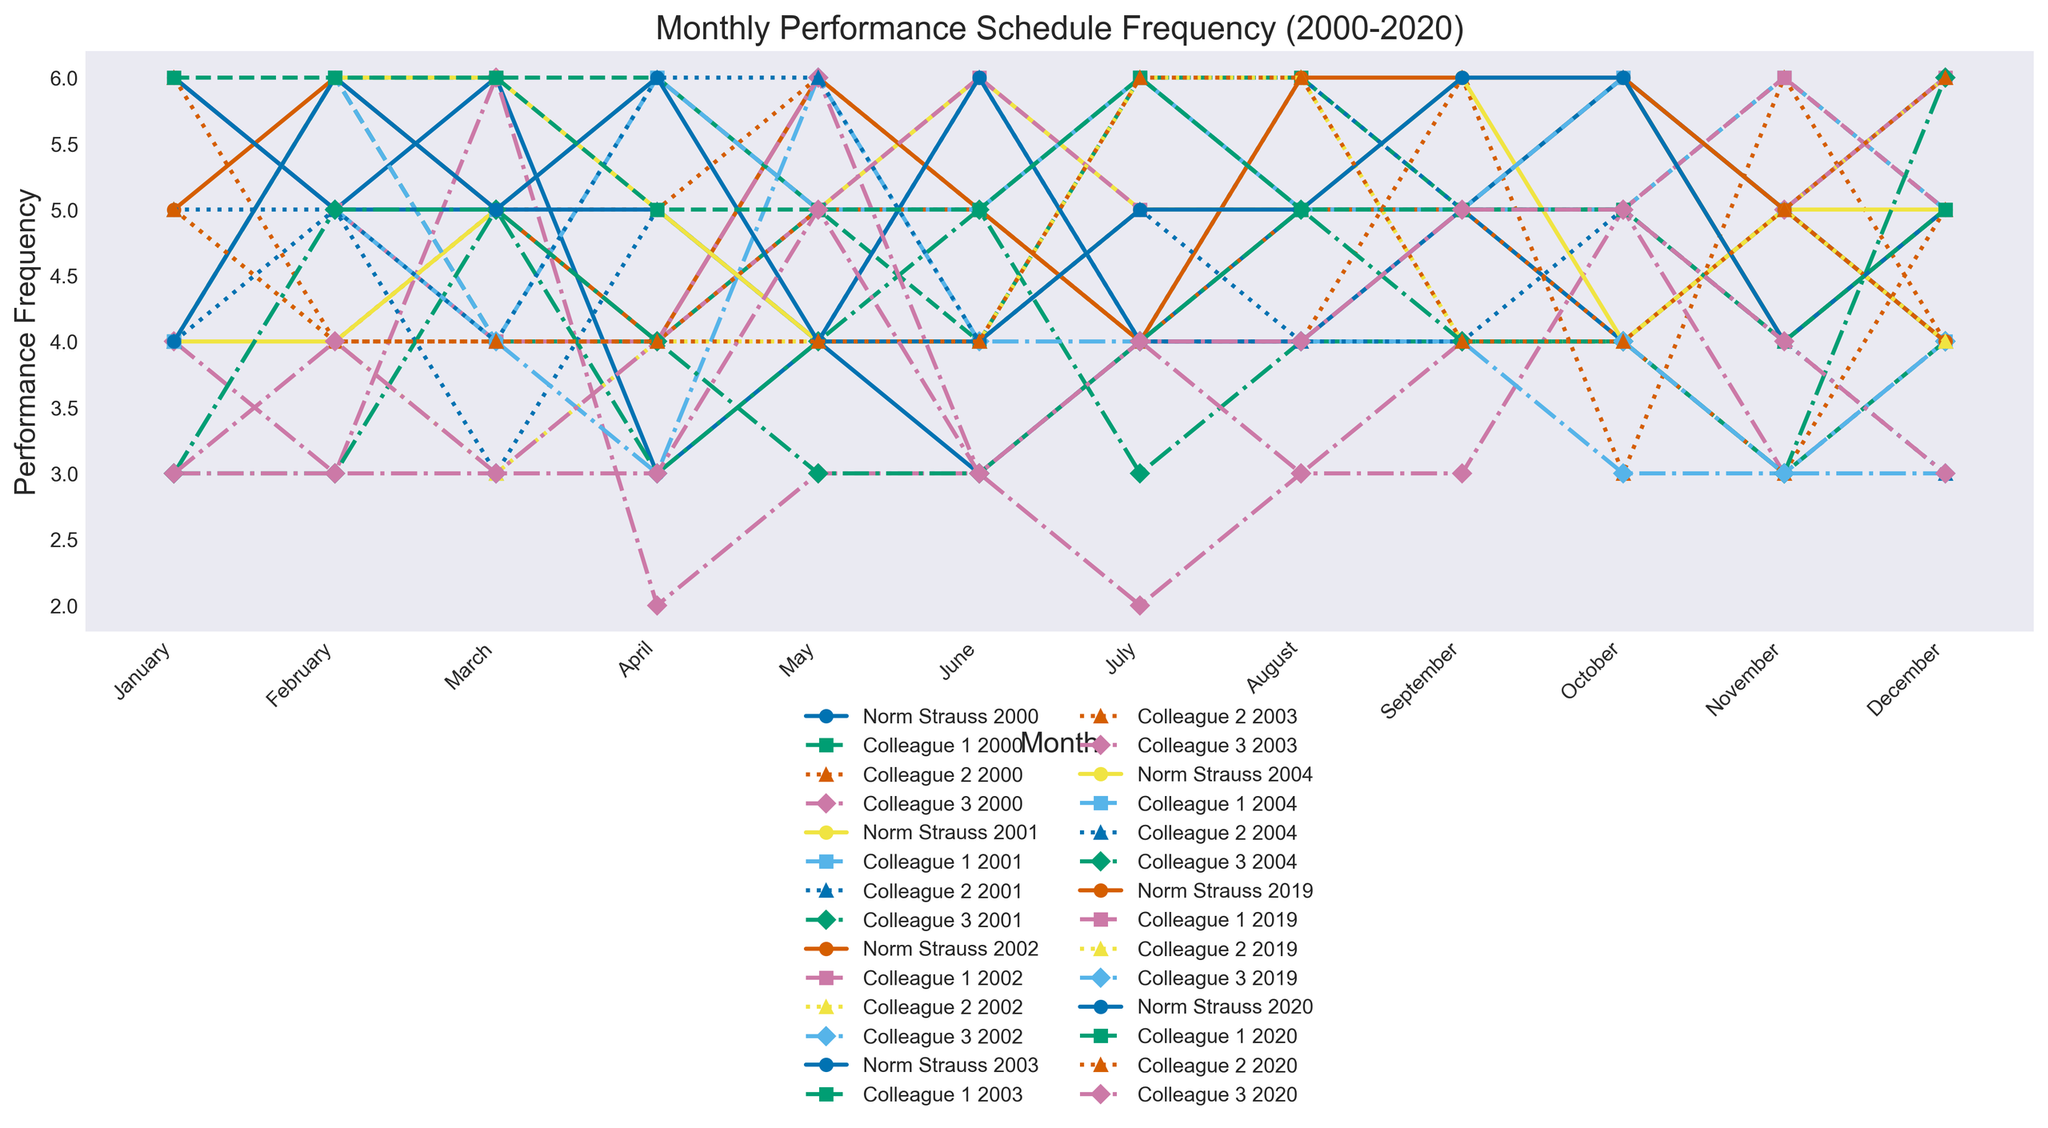How does the performance frequency of Norm Strauss in June 2000 compare to that of Colleague 1 in the same month? In June 2000, Norm Strauss had 4 performances while Colleague 1 had 6 performances. A direct comparison shows that Colleague 1 had more performances in June 2000 than Norm Strauss.
Answer: Colleague 1 had more performances During the year 2001, which month did Norm Strauss perform the most, and how many performances were there? Observing the line chart for 2001, Norm Strauss had the highest performance frequency in February with 6 performances.
Answer: February, 6 Who had the highest number of performances in April 2002? By looking at the performance frequencies for April 2002, we see that Norm Strauss and Colleague 2 both had 6 performances, which is the highest for that month.
Answer: Norm Strauss and Colleague 2 What is the median number of June performances for Colleague 3 from 2000 to 2020? To find the median, list the June performance frequencies for Colleague 3 (2, 3, 4, 4, 4, 3, 4) and determine the middle value. The performance frequencies are already sorted, and the middle value is 4.
Answer: 4 Which month in 2004 had the most performances from all musicians combined, and what is the total number? Adding up the performances for each month in 2004 and comparing totals, August has the highest combined performances. Norm Strauss (6) + Colleague 1 (6) + Colleague 2 (5) + Colleague 3 (5) = 22 performances in August.
Answer: August, 22 What is the difference in the average number of performances between Norm Strauss and Colleague 2 for the year 2001? First, calculate the average performances per month for both. Norm Strauss: (5+6+5+4+5+5+6+4+5+4+6+5)/12 = 5; Colleague 2: (4+5+6+4+5+4+6+5+4+5+6+3)/12 = 4.92. The difference is
Answer: 5 - 4.92 = 0.08 In which year did Colleague 1 perform exactly 6 times in both February and March? By examining the line chart for February and March over the years, Colleague 1 performed 6 times in both months in 2001.
Answer: 2001 How does the performance frequency of Colleague 3 in December 2000 compare to December 2020? In December 2000, Colleague 3 performed 6 times, while in December 2020, they performed 3 times. Therefore, Colleague 3 performed more often in December 2000 compared to December 2020.
Answer: More in December 2000 What is the total number of performances by Norm Strauss and Colleague 3 in January from 2000 to 2002? Summing up performances in January for each year: Norm Strauss (4 in 2000 + 5 in 2001 + 6 in 2002) = 15; Colleague 3 (3 in 2000 + 4 in 2001 + 6 in 2002) = 13. Total combined performances = 15 + 13 = 28.
Answer: 28 